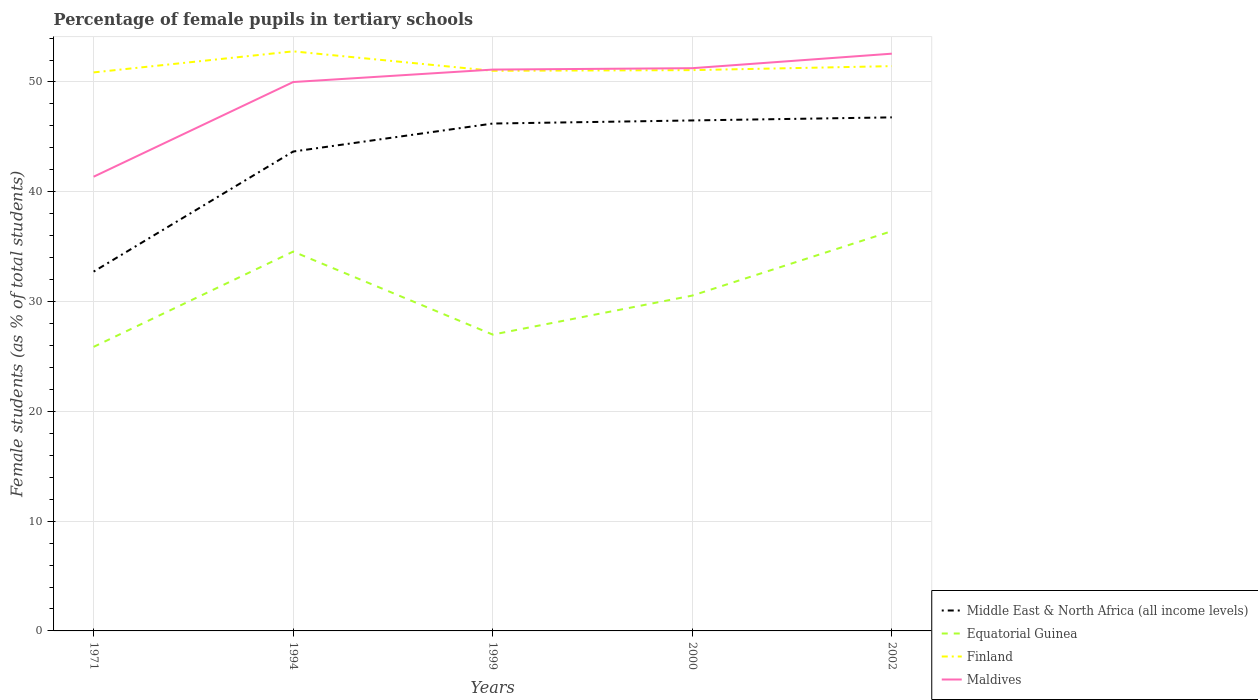How many different coloured lines are there?
Give a very brief answer. 4. Does the line corresponding to Finland intersect with the line corresponding to Equatorial Guinea?
Your response must be concise. No. Is the number of lines equal to the number of legend labels?
Provide a short and direct response. Yes. Across all years, what is the maximum percentage of female pupils in tertiary schools in Equatorial Guinea?
Give a very brief answer. 25.87. In which year was the percentage of female pupils in tertiary schools in Maldives maximum?
Your response must be concise. 1971. What is the total percentage of female pupils in tertiary schools in Equatorial Guinea in the graph?
Provide a short and direct response. -5.87. What is the difference between the highest and the second highest percentage of female pupils in tertiary schools in Middle East & North Africa (all income levels)?
Your response must be concise. 14.05. What is the difference between the highest and the lowest percentage of female pupils in tertiary schools in Middle East & North Africa (all income levels)?
Your answer should be compact. 4. How many lines are there?
Keep it short and to the point. 4. How many years are there in the graph?
Your answer should be very brief. 5. Does the graph contain grids?
Provide a succinct answer. Yes. How are the legend labels stacked?
Keep it short and to the point. Vertical. What is the title of the graph?
Your response must be concise. Percentage of female pupils in tertiary schools. Does "Kazakhstan" appear as one of the legend labels in the graph?
Ensure brevity in your answer.  No. What is the label or title of the X-axis?
Ensure brevity in your answer.  Years. What is the label or title of the Y-axis?
Your response must be concise. Female students (as % of total students). What is the Female students (as % of total students) of Middle East & North Africa (all income levels) in 1971?
Provide a succinct answer. 32.73. What is the Female students (as % of total students) in Equatorial Guinea in 1971?
Provide a short and direct response. 25.87. What is the Female students (as % of total students) of Finland in 1971?
Give a very brief answer. 50.87. What is the Female students (as % of total students) of Maldives in 1971?
Ensure brevity in your answer.  41.37. What is the Female students (as % of total students) in Middle East & North Africa (all income levels) in 1994?
Ensure brevity in your answer.  43.66. What is the Female students (as % of total students) in Equatorial Guinea in 1994?
Your answer should be very brief. 34.55. What is the Female students (as % of total students) in Finland in 1994?
Provide a short and direct response. 52.79. What is the Female students (as % of total students) in Maldives in 1994?
Your answer should be compact. 49.99. What is the Female students (as % of total students) in Middle East & North Africa (all income levels) in 1999?
Give a very brief answer. 46.21. What is the Female students (as % of total students) of Equatorial Guinea in 1999?
Provide a short and direct response. 26.99. What is the Female students (as % of total students) in Finland in 1999?
Your response must be concise. 51.02. What is the Female students (as % of total students) of Maldives in 1999?
Your response must be concise. 51.13. What is the Female students (as % of total students) in Middle East & North Africa (all income levels) in 2000?
Keep it short and to the point. 46.5. What is the Female students (as % of total students) of Equatorial Guinea in 2000?
Offer a very short reply. 30.54. What is the Female students (as % of total students) of Finland in 2000?
Your answer should be very brief. 51.08. What is the Female students (as % of total students) of Maldives in 2000?
Your answer should be very brief. 51.25. What is the Female students (as % of total students) of Middle East & North Africa (all income levels) in 2002?
Ensure brevity in your answer.  46.78. What is the Female students (as % of total students) of Equatorial Guinea in 2002?
Offer a very short reply. 36.41. What is the Female students (as % of total students) in Finland in 2002?
Provide a succinct answer. 51.44. What is the Female students (as % of total students) in Maldives in 2002?
Provide a short and direct response. 52.58. Across all years, what is the maximum Female students (as % of total students) in Middle East & North Africa (all income levels)?
Provide a short and direct response. 46.78. Across all years, what is the maximum Female students (as % of total students) of Equatorial Guinea?
Your response must be concise. 36.41. Across all years, what is the maximum Female students (as % of total students) of Finland?
Provide a succinct answer. 52.79. Across all years, what is the maximum Female students (as % of total students) of Maldives?
Give a very brief answer. 52.58. Across all years, what is the minimum Female students (as % of total students) of Middle East & North Africa (all income levels)?
Ensure brevity in your answer.  32.73. Across all years, what is the minimum Female students (as % of total students) in Equatorial Guinea?
Provide a short and direct response. 25.87. Across all years, what is the minimum Female students (as % of total students) in Finland?
Your answer should be very brief. 50.87. Across all years, what is the minimum Female students (as % of total students) of Maldives?
Make the answer very short. 41.37. What is the total Female students (as % of total students) in Middle East & North Africa (all income levels) in the graph?
Give a very brief answer. 215.87. What is the total Female students (as % of total students) in Equatorial Guinea in the graph?
Ensure brevity in your answer.  154.37. What is the total Female students (as % of total students) of Finland in the graph?
Ensure brevity in your answer.  257.2. What is the total Female students (as % of total students) of Maldives in the graph?
Offer a very short reply. 246.32. What is the difference between the Female students (as % of total students) of Middle East & North Africa (all income levels) in 1971 and that in 1994?
Offer a very short reply. -10.94. What is the difference between the Female students (as % of total students) of Equatorial Guinea in 1971 and that in 1994?
Your response must be concise. -8.68. What is the difference between the Female students (as % of total students) of Finland in 1971 and that in 1994?
Provide a succinct answer. -1.92. What is the difference between the Female students (as % of total students) in Maldives in 1971 and that in 1994?
Offer a terse response. -8.62. What is the difference between the Female students (as % of total students) of Middle East & North Africa (all income levels) in 1971 and that in 1999?
Give a very brief answer. -13.49. What is the difference between the Female students (as % of total students) of Equatorial Guinea in 1971 and that in 1999?
Your answer should be very brief. -1.12. What is the difference between the Female students (as % of total students) of Finland in 1971 and that in 1999?
Offer a terse response. -0.15. What is the difference between the Female students (as % of total students) of Maldives in 1971 and that in 1999?
Your response must be concise. -9.76. What is the difference between the Female students (as % of total students) in Middle East & North Africa (all income levels) in 1971 and that in 2000?
Make the answer very short. -13.77. What is the difference between the Female students (as % of total students) of Equatorial Guinea in 1971 and that in 2000?
Ensure brevity in your answer.  -4.67. What is the difference between the Female students (as % of total students) of Finland in 1971 and that in 2000?
Keep it short and to the point. -0.21. What is the difference between the Female students (as % of total students) in Maldives in 1971 and that in 2000?
Give a very brief answer. -9.89. What is the difference between the Female students (as % of total students) of Middle East & North Africa (all income levels) in 1971 and that in 2002?
Your answer should be compact. -14.05. What is the difference between the Female students (as % of total students) of Equatorial Guinea in 1971 and that in 2002?
Make the answer very short. -10.54. What is the difference between the Female students (as % of total students) in Finland in 1971 and that in 2002?
Your answer should be compact. -0.57. What is the difference between the Female students (as % of total students) in Maldives in 1971 and that in 2002?
Give a very brief answer. -11.21. What is the difference between the Female students (as % of total students) in Middle East & North Africa (all income levels) in 1994 and that in 1999?
Provide a succinct answer. -2.55. What is the difference between the Female students (as % of total students) of Equatorial Guinea in 1994 and that in 1999?
Provide a short and direct response. 7.56. What is the difference between the Female students (as % of total students) in Finland in 1994 and that in 1999?
Make the answer very short. 1.77. What is the difference between the Female students (as % of total students) in Maldives in 1994 and that in 1999?
Ensure brevity in your answer.  -1.13. What is the difference between the Female students (as % of total students) of Middle East & North Africa (all income levels) in 1994 and that in 2000?
Offer a very short reply. -2.83. What is the difference between the Female students (as % of total students) in Equatorial Guinea in 1994 and that in 2000?
Keep it short and to the point. 4.01. What is the difference between the Female students (as % of total students) in Finland in 1994 and that in 2000?
Provide a succinct answer. 1.71. What is the difference between the Female students (as % of total students) in Maldives in 1994 and that in 2000?
Your answer should be compact. -1.26. What is the difference between the Female students (as % of total students) in Middle East & North Africa (all income levels) in 1994 and that in 2002?
Offer a terse response. -3.11. What is the difference between the Female students (as % of total students) of Equatorial Guinea in 1994 and that in 2002?
Offer a terse response. -1.86. What is the difference between the Female students (as % of total students) in Finland in 1994 and that in 2002?
Give a very brief answer. 1.35. What is the difference between the Female students (as % of total students) of Maldives in 1994 and that in 2002?
Your response must be concise. -2.58. What is the difference between the Female students (as % of total students) of Middle East & North Africa (all income levels) in 1999 and that in 2000?
Provide a succinct answer. -0.28. What is the difference between the Female students (as % of total students) in Equatorial Guinea in 1999 and that in 2000?
Provide a succinct answer. -3.55. What is the difference between the Female students (as % of total students) of Finland in 1999 and that in 2000?
Make the answer very short. -0.06. What is the difference between the Female students (as % of total students) of Maldives in 1999 and that in 2000?
Offer a terse response. -0.13. What is the difference between the Female students (as % of total students) in Middle East & North Africa (all income levels) in 1999 and that in 2002?
Offer a terse response. -0.56. What is the difference between the Female students (as % of total students) in Equatorial Guinea in 1999 and that in 2002?
Keep it short and to the point. -9.42. What is the difference between the Female students (as % of total students) of Finland in 1999 and that in 2002?
Your answer should be very brief. -0.42. What is the difference between the Female students (as % of total students) of Maldives in 1999 and that in 2002?
Make the answer very short. -1.45. What is the difference between the Female students (as % of total students) of Middle East & North Africa (all income levels) in 2000 and that in 2002?
Ensure brevity in your answer.  -0.28. What is the difference between the Female students (as % of total students) of Equatorial Guinea in 2000 and that in 2002?
Ensure brevity in your answer.  -5.87. What is the difference between the Female students (as % of total students) of Finland in 2000 and that in 2002?
Offer a very short reply. -0.37. What is the difference between the Female students (as % of total students) of Maldives in 2000 and that in 2002?
Ensure brevity in your answer.  -1.32. What is the difference between the Female students (as % of total students) of Middle East & North Africa (all income levels) in 1971 and the Female students (as % of total students) of Equatorial Guinea in 1994?
Your response must be concise. -1.82. What is the difference between the Female students (as % of total students) in Middle East & North Africa (all income levels) in 1971 and the Female students (as % of total students) in Finland in 1994?
Ensure brevity in your answer.  -20.06. What is the difference between the Female students (as % of total students) in Middle East & North Africa (all income levels) in 1971 and the Female students (as % of total students) in Maldives in 1994?
Your answer should be compact. -17.27. What is the difference between the Female students (as % of total students) of Equatorial Guinea in 1971 and the Female students (as % of total students) of Finland in 1994?
Provide a short and direct response. -26.92. What is the difference between the Female students (as % of total students) of Equatorial Guinea in 1971 and the Female students (as % of total students) of Maldives in 1994?
Your answer should be very brief. -24.12. What is the difference between the Female students (as % of total students) of Finland in 1971 and the Female students (as % of total students) of Maldives in 1994?
Provide a short and direct response. 0.88. What is the difference between the Female students (as % of total students) of Middle East & North Africa (all income levels) in 1971 and the Female students (as % of total students) of Equatorial Guinea in 1999?
Your response must be concise. 5.74. What is the difference between the Female students (as % of total students) in Middle East & North Africa (all income levels) in 1971 and the Female students (as % of total students) in Finland in 1999?
Your answer should be compact. -18.29. What is the difference between the Female students (as % of total students) of Middle East & North Africa (all income levels) in 1971 and the Female students (as % of total students) of Maldives in 1999?
Offer a terse response. -18.4. What is the difference between the Female students (as % of total students) in Equatorial Guinea in 1971 and the Female students (as % of total students) in Finland in 1999?
Provide a short and direct response. -25.14. What is the difference between the Female students (as % of total students) in Equatorial Guinea in 1971 and the Female students (as % of total students) in Maldives in 1999?
Offer a terse response. -25.25. What is the difference between the Female students (as % of total students) in Finland in 1971 and the Female students (as % of total students) in Maldives in 1999?
Ensure brevity in your answer.  -0.26. What is the difference between the Female students (as % of total students) of Middle East & North Africa (all income levels) in 1971 and the Female students (as % of total students) of Equatorial Guinea in 2000?
Your answer should be compact. 2.18. What is the difference between the Female students (as % of total students) in Middle East & North Africa (all income levels) in 1971 and the Female students (as % of total students) in Finland in 2000?
Your answer should be compact. -18.35. What is the difference between the Female students (as % of total students) in Middle East & North Africa (all income levels) in 1971 and the Female students (as % of total students) in Maldives in 2000?
Provide a succinct answer. -18.53. What is the difference between the Female students (as % of total students) in Equatorial Guinea in 1971 and the Female students (as % of total students) in Finland in 2000?
Give a very brief answer. -25.2. What is the difference between the Female students (as % of total students) of Equatorial Guinea in 1971 and the Female students (as % of total students) of Maldives in 2000?
Your response must be concise. -25.38. What is the difference between the Female students (as % of total students) in Finland in 1971 and the Female students (as % of total students) in Maldives in 2000?
Give a very brief answer. -0.38. What is the difference between the Female students (as % of total students) in Middle East & North Africa (all income levels) in 1971 and the Female students (as % of total students) in Equatorial Guinea in 2002?
Provide a succinct answer. -3.69. What is the difference between the Female students (as % of total students) of Middle East & North Africa (all income levels) in 1971 and the Female students (as % of total students) of Finland in 2002?
Provide a short and direct response. -18.72. What is the difference between the Female students (as % of total students) of Middle East & North Africa (all income levels) in 1971 and the Female students (as % of total students) of Maldives in 2002?
Offer a very short reply. -19.85. What is the difference between the Female students (as % of total students) of Equatorial Guinea in 1971 and the Female students (as % of total students) of Finland in 2002?
Provide a short and direct response. -25.57. What is the difference between the Female students (as % of total students) of Equatorial Guinea in 1971 and the Female students (as % of total students) of Maldives in 2002?
Give a very brief answer. -26.7. What is the difference between the Female students (as % of total students) of Finland in 1971 and the Female students (as % of total students) of Maldives in 2002?
Your answer should be very brief. -1.71. What is the difference between the Female students (as % of total students) in Middle East & North Africa (all income levels) in 1994 and the Female students (as % of total students) in Equatorial Guinea in 1999?
Ensure brevity in your answer.  16.67. What is the difference between the Female students (as % of total students) of Middle East & North Africa (all income levels) in 1994 and the Female students (as % of total students) of Finland in 1999?
Provide a succinct answer. -7.35. What is the difference between the Female students (as % of total students) of Middle East & North Africa (all income levels) in 1994 and the Female students (as % of total students) of Maldives in 1999?
Provide a short and direct response. -7.46. What is the difference between the Female students (as % of total students) in Equatorial Guinea in 1994 and the Female students (as % of total students) in Finland in 1999?
Give a very brief answer. -16.47. What is the difference between the Female students (as % of total students) in Equatorial Guinea in 1994 and the Female students (as % of total students) in Maldives in 1999?
Provide a succinct answer. -16.58. What is the difference between the Female students (as % of total students) of Finland in 1994 and the Female students (as % of total students) of Maldives in 1999?
Your answer should be very brief. 1.66. What is the difference between the Female students (as % of total students) of Middle East & North Africa (all income levels) in 1994 and the Female students (as % of total students) of Equatorial Guinea in 2000?
Give a very brief answer. 13.12. What is the difference between the Female students (as % of total students) of Middle East & North Africa (all income levels) in 1994 and the Female students (as % of total students) of Finland in 2000?
Ensure brevity in your answer.  -7.41. What is the difference between the Female students (as % of total students) in Middle East & North Africa (all income levels) in 1994 and the Female students (as % of total students) in Maldives in 2000?
Offer a very short reply. -7.59. What is the difference between the Female students (as % of total students) in Equatorial Guinea in 1994 and the Female students (as % of total students) in Finland in 2000?
Give a very brief answer. -16.53. What is the difference between the Female students (as % of total students) in Equatorial Guinea in 1994 and the Female students (as % of total students) in Maldives in 2000?
Give a very brief answer. -16.7. What is the difference between the Female students (as % of total students) of Finland in 1994 and the Female students (as % of total students) of Maldives in 2000?
Your answer should be compact. 1.53. What is the difference between the Female students (as % of total students) in Middle East & North Africa (all income levels) in 1994 and the Female students (as % of total students) in Equatorial Guinea in 2002?
Keep it short and to the point. 7.25. What is the difference between the Female students (as % of total students) in Middle East & North Africa (all income levels) in 1994 and the Female students (as % of total students) in Finland in 2002?
Provide a succinct answer. -7.78. What is the difference between the Female students (as % of total students) in Middle East & North Africa (all income levels) in 1994 and the Female students (as % of total students) in Maldives in 2002?
Provide a succinct answer. -8.91. What is the difference between the Female students (as % of total students) in Equatorial Guinea in 1994 and the Female students (as % of total students) in Finland in 2002?
Give a very brief answer. -16.89. What is the difference between the Female students (as % of total students) in Equatorial Guinea in 1994 and the Female students (as % of total students) in Maldives in 2002?
Provide a succinct answer. -18.03. What is the difference between the Female students (as % of total students) of Finland in 1994 and the Female students (as % of total students) of Maldives in 2002?
Give a very brief answer. 0.21. What is the difference between the Female students (as % of total students) of Middle East & North Africa (all income levels) in 1999 and the Female students (as % of total students) of Equatorial Guinea in 2000?
Your answer should be compact. 15.67. What is the difference between the Female students (as % of total students) in Middle East & North Africa (all income levels) in 1999 and the Female students (as % of total students) in Finland in 2000?
Keep it short and to the point. -4.86. What is the difference between the Female students (as % of total students) in Middle East & North Africa (all income levels) in 1999 and the Female students (as % of total students) in Maldives in 2000?
Offer a terse response. -5.04. What is the difference between the Female students (as % of total students) of Equatorial Guinea in 1999 and the Female students (as % of total students) of Finland in 2000?
Your answer should be very brief. -24.09. What is the difference between the Female students (as % of total students) of Equatorial Guinea in 1999 and the Female students (as % of total students) of Maldives in 2000?
Ensure brevity in your answer.  -24.26. What is the difference between the Female students (as % of total students) of Finland in 1999 and the Female students (as % of total students) of Maldives in 2000?
Ensure brevity in your answer.  -0.24. What is the difference between the Female students (as % of total students) in Middle East & North Africa (all income levels) in 1999 and the Female students (as % of total students) in Equatorial Guinea in 2002?
Offer a terse response. 9.8. What is the difference between the Female students (as % of total students) in Middle East & North Africa (all income levels) in 1999 and the Female students (as % of total students) in Finland in 2002?
Give a very brief answer. -5.23. What is the difference between the Female students (as % of total students) in Middle East & North Africa (all income levels) in 1999 and the Female students (as % of total students) in Maldives in 2002?
Make the answer very short. -6.36. What is the difference between the Female students (as % of total students) of Equatorial Guinea in 1999 and the Female students (as % of total students) of Finland in 2002?
Your answer should be compact. -24.45. What is the difference between the Female students (as % of total students) in Equatorial Guinea in 1999 and the Female students (as % of total students) in Maldives in 2002?
Provide a succinct answer. -25.59. What is the difference between the Female students (as % of total students) of Finland in 1999 and the Female students (as % of total students) of Maldives in 2002?
Keep it short and to the point. -1.56. What is the difference between the Female students (as % of total students) of Middle East & North Africa (all income levels) in 2000 and the Female students (as % of total students) of Equatorial Guinea in 2002?
Make the answer very short. 10.08. What is the difference between the Female students (as % of total students) of Middle East & North Africa (all income levels) in 2000 and the Female students (as % of total students) of Finland in 2002?
Offer a very short reply. -4.95. What is the difference between the Female students (as % of total students) in Middle East & North Africa (all income levels) in 2000 and the Female students (as % of total students) in Maldives in 2002?
Offer a terse response. -6.08. What is the difference between the Female students (as % of total students) of Equatorial Guinea in 2000 and the Female students (as % of total students) of Finland in 2002?
Offer a very short reply. -20.9. What is the difference between the Female students (as % of total students) in Equatorial Guinea in 2000 and the Female students (as % of total students) in Maldives in 2002?
Your answer should be compact. -22.03. What is the difference between the Female students (as % of total students) in Finland in 2000 and the Female students (as % of total students) in Maldives in 2002?
Provide a succinct answer. -1.5. What is the average Female students (as % of total students) in Middle East & North Africa (all income levels) per year?
Provide a short and direct response. 43.17. What is the average Female students (as % of total students) in Equatorial Guinea per year?
Your answer should be very brief. 30.87. What is the average Female students (as % of total students) in Finland per year?
Keep it short and to the point. 51.44. What is the average Female students (as % of total students) of Maldives per year?
Ensure brevity in your answer.  49.26. In the year 1971, what is the difference between the Female students (as % of total students) in Middle East & North Africa (all income levels) and Female students (as % of total students) in Equatorial Guinea?
Your answer should be compact. 6.85. In the year 1971, what is the difference between the Female students (as % of total students) in Middle East & North Africa (all income levels) and Female students (as % of total students) in Finland?
Your answer should be very brief. -18.14. In the year 1971, what is the difference between the Female students (as % of total students) of Middle East & North Africa (all income levels) and Female students (as % of total students) of Maldives?
Your answer should be compact. -8.64. In the year 1971, what is the difference between the Female students (as % of total students) of Equatorial Guinea and Female students (as % of total students) of Finland?
Make the answer very short. -25. In the year 1971, what is the difference between the Female students (as % of total students) in Equatorial Guinea and Female students (as % of total students) in Maldives?
Provide a short and direct response. -15.5. In the year 1971, what is the difference between the Female students (as % of total students) in Finland and Female students (as % of total students) in Maldives?
Your answer should be compact. 9.5. In the year 1994, what is the difference between the Female students (as % of total students) of Middle East & North Africa (all income levels) and Female students (as % of total students) of Equatorial Guinea?
Your answer should be compact. 9.11. In the year 1994, what is the difference between the Female students (as % of total students) of Middle East & North Africa (all income levels) and Female students (as % of total students) of Finland?
Provide a short and direct response. -9.12. In the year 1994, what is the difference between the Female students (as % of total students) of Middle East & North Africa (all income levels) and Female students (as % of total students) of Maldives?
Offer a very short reply. -6.33. In the year 1994, what is the difference between the Female students (as % of total students) in Equatorial Guinea and Female students (as % of total students) in Finland?
Make the answer very short. -18.24. In the year 1994, what is the difference between the Female students (as % of total students) of Equatorial Guinea and Female students (as % of total students) of Maldives?
Make the answer very short. -15.44. In the year 1994, what is the difference between the Female students (as % of total students) in Finland and Female students (as % of total students) in Maldives?
Offer a terse response. 2.8. In the year 1999, what is the difference between the Female students (as % of total students) in Middle East & North Africa (all income levels) and Female students (as % of total students) in Equatorial Guinea?
Your answer should be very brief. 19.22. In the year 1999, what is the difference between the Female students (as % of total students) of Middle East & North Africa (all income levels) and Female students (as % of total students) of Finland?
Your response must be concise. -4.8. In the year 1999, what is the difference between the Female students (as % of total students) of Middle East & North Africa (all income levels) and Female students (as % of total students) of Maldives?
Provide a succinct answer. -4.91. In the year 1999, what is the difference between the Female students (as % of total students) in Equatorial Guinea and Female students (as % of total students) in Finland?
Your answer should be very brief. -24.03. In the year 1999, what is the difference between the Female students (as % of total students) in Equatorial Guinea and Female students (as % of total students) in Maldives?
Provide a succinct answer. -24.14. In the year 1999, what is the difference between the Female students (as % of total students) in Finland and Female students (as % of total students) in Maldives?
Your answer should be very brief. -0.11. In the year 2000, what is the difference between the Female students (as % of total students) of Middle East & North Africa (all income levels) and Female students (as % of total students) of Equatorial Guinea?
Provide a short and direct response. 15.95. In the year 2000, what is the difference between the Female students (as % of total students) in Middle East & North Africa (all income levels) and Female students (as % of total students) in Finland?
Provide a short and direct response. -4.58. In the year 2000, what is the difference between the Female students (as % of total students) of Middle East & North Africa (all income levels) and Female students (as % of total students) of Maldives?
Make the answer very short. -4.76. In the year 2000, what is the difference between the Female students (as % of total students) in Equatorial Guinea and Female students (as % of total students) in Finland?
Provide a succinct answer. -20.53. In the year 2000, what is the difference between the Female students (as % of total students) of Equatorial Guinea and Female students (as % of total students) of Maldives?
Offer a very short reply. -20.71. In the year 2000, what is the difference between the Female students (as % of total students) in Finland and Female students (as % of total students) in Maldives?
Make the answer very short. -0.18. In the year 2002, what is the difference between the Female students (as % of total students) in Middle East & North Africa (all income levels) and Female students (as % of total students) in Equatorial Guinea?
Make the answer very short. 10.36. In the year 2002, what is the difference between the Female students (as % of total students) of Middle East & North Africa (all income levels) and Female students (as % of total students) of Finland?
Your answer should be compact. -4.67. In the year 2002, what is the difference between the Female students (as % of total students) in Middle East & North Africa (all income levels) and Female students (as % of total students) in Maldives?
Keep it short and to the point. -5.8. In the year 2002, what is the difference between the Female students (as % of total students) in Equatorial Guinea and Female students (as % of total students) in Finland?
Ensure brevity in your answer.  -15.03. In the year 2002, what is the difference between the Female students (as % of total students) of Equatorial Guinea and Female students (as % of total students) of Maldives?
Keep it short and to the point. -16.16. In the year 2002, what is the difference between the Female students (as % of total students) in Finland and Female students (as % of total students) in Maldives?
Offer a very short reply. -1.13. What is the ratio of the Female students (as % of total students) of Middle East & North Africa (all income levels) in 1971 to that in 1994?
Provide a short and direct response. 0.75. What is the ratio of the Female students (as % of total students) in Equatorial Guinea in 1971 to that in 1994?
Offer a terse response. 0.75. What is the ratio of the Female students (as % of total students) in Finland in 1971 to that in 1994?
Your response must be concise. 0.96. What is the ratio of the Female students (as % of total students) in Maldives in 1971 to that in 1994?
Your answer should be compact. 0.83. What is the ratio of the Female students (as % of total students) of Middle East & North Africa (all income levels) in 1971 to that in 1999?
Keep it short and to the point. 0.71. What is the ratio of the Female students (as % of total students) in Equatorial Guinea in 1971 to that in 1999?
Your answer should be very brief. 0.96. What is the ratio of the Female students (as % of total students) of Finland in 1971 to that in 1999?
Offer a terse response. 1. What is the ratio of the Female students (as % of total students) of Maldives in 1971 to that in 1999?
Offer a very short reply. 0.81. What is the ratio of the Female students (as % of total students) in Middle East & North Africa (all income levels) in 1971 to that in 2000?
Keep it short and to the point. 0.7. What is the ratio of the Female students (as % of total students) of Equatorial Guinea in 1971 to that in 2000?
Ensure brevity in your answer.  0.85. What is the ratio of the Female students (as % of total students) in Finland in 1971 to that in 2000?
Keep it short and to the point. 1. What is the ratio of the Female students (as % of total students) in Maldives in 1971 to that in 2000?
Keep it short and to the point. 0.81. What is the ratio of the Female students (as % of total students) in Middle East & North Africa (all income levels) in 1971 to that in 2002?
Provide a succinct answer. 0.7. What is the ratio of the Female students (as % of total students) of Equatorial Guinea in 1971 to that in 2002?
Your response must be concise. 0.71. What is the ratio of the Female students (as % of total students) in Finland in 1971 to that in 2002?
Your answer should be very brief. 0.99. What is the ratio of the Female students (as % of total students) of Maldives in 1971 to that in 2002?
Your answer should be very brief. 0.79. What is the ratio of the Female students (as % of total students) of Middle East & North Africa (all income levels) in 1994 to that in 1999?
Ensure brevity in your answer.  0.94. What is the ratio of the Female students (as % of total students) in Equatorial Guinea in 1994 to that in 1999?
Provide a short and direct response. 1.28. What is the ratio of the Female students (as % of total students) of Finland in 1994 to that in 1999?
Provide a succinct answer. 1.03. What is the ratio of the Female students (as % of total students) of Maldives in 1994 to that in 1999?
Provide a succinct answer. 0.98. What is the ratio of the Female students (as % of total students) in Middle East & North Africa (all income levels) in 1994 to that in 2000?
Offer a terse response. 0.94. What is the ratio of the Female students (as % of total students) in Equatorial Guinea in 1994 to that in 2000?
Offer a very short reply. 1.13. What is the ratio of the Female students (as % of total students) of Finland in 1994 to that in 2000?
Your answer should be compact. 1.03. What is the ratio of the Female students (as % of total students) in Maldives in 1994 to that in 2000?
Provide a succinct answer. 0.98. What is the ratio of the Female students (as % of total students) in Middle East & North Africa (all income levels) in 1994 to that in 2002?
Provide a succinct answer. 0.93. What is the ratio of the Female students (as % of total students) in Equatorial Guinea in 1994 to that in 2002?
Offer a very short reply. 0.95. What is the ratio of the Female students (as % of total students) in Finland in 1994 to that in 2002?
Provide a short and direct response. 1.03. What is the ratio of the Female students (as % of total students) of Maldives in 1994 to that in 2002?
Keep it short and to the point. 0.95. What is the ratio of the Female students (as % of total students) in Middle East & North Africa (all income levels) in 1999 to that in 2000?
Your answer should be compact. 0.99. What is the ratio of the Female students (as % of total students) in Equatorial Guinea in 1999 to that in 2000?
Make the answer very short. 0.88. What is the ratio of the Female students (as % of total students) of Finland in 1999 to that in 2000?
Your response must be concise. 1. What is the ratio of the Female students (as % of total students) in Equatorial Guinea in 1999 to that in 2002?
Make the answer very short. 0.74. What is the ratio of the Female students (as % of total students) of Finland in 1999 to that in 2002?
Provide a succinct answer. 0.99. What is the ratio of the Female students (as % of total students) in Maldives in 1999 to that in 2002?
Ensure brevity in your answer.  0.97. What is the ratio of the Female students (as % of total students) in Middle East & North Africa (all income levels) in 2000 to that in 2002?
Your answer should be very brief. 0.99. What is the ratio of the Female students (as % of total students) in Equatorial Guinea in 2000 to that in 2002?
Provide a short and direct response. 0.84. What is the ratio of the Female students (as % of total students) of Maldives in 2000 to that in 2002?
Ensure brevity in your answer.  0.97. What is the difference between the highest and the second highest Female students (as % of total students) in Middle East & North Africa (all income levels)?
Offer a very short reply. 0.28. What is the difference between the highest and the second highest Female students (as % of total students) of Equatorial Guinea?
Your answer should be very brief. 1.86. What is the difference between the highest and the second highest Female students (as % of total students) in Finland?
Offer a very short reply. 1.35. What is the difference between the highest and the second highest Female students (as % of total students) in Maldives?
Your response must be concise. 1.32. What is the difference between the highest and the lowest Female students (as % of total students) in Middle East & North Africa (all income levels)?
Keep it short and to the point. 14.05. What is the difference between the highest and the lowest Female students (as % of total students) of Equatorial Guinea?
Give a very brief answer. 10.54. What is the difference between the highest and the lowest Female students (as % of total students) of Finland?
Offer a very short reply. 1.92. What is the difference between the highest and the lowest Female students (as % of total students) in Maldives?
Offer a very short reply. 11.21. 